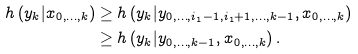<formula> <loc_0><loc_0><loc_500><loc_500>h \left ( y _ { k } | x _ { 0 , \dots , k } \right ) & \geq h \left ( y _ { k } | y _ { 0 , \dots , i _ { 1 } - 1 , i _ { 1 } + 1 , \dots , k - 1 } , x _ { 0 , \dots , k } \right ) \\ & \geq h \left ( y _ { k } | y _ { 0 , \dots , k - 1 } , x _ { 0 , \dots , k } \right ) .</formula> 